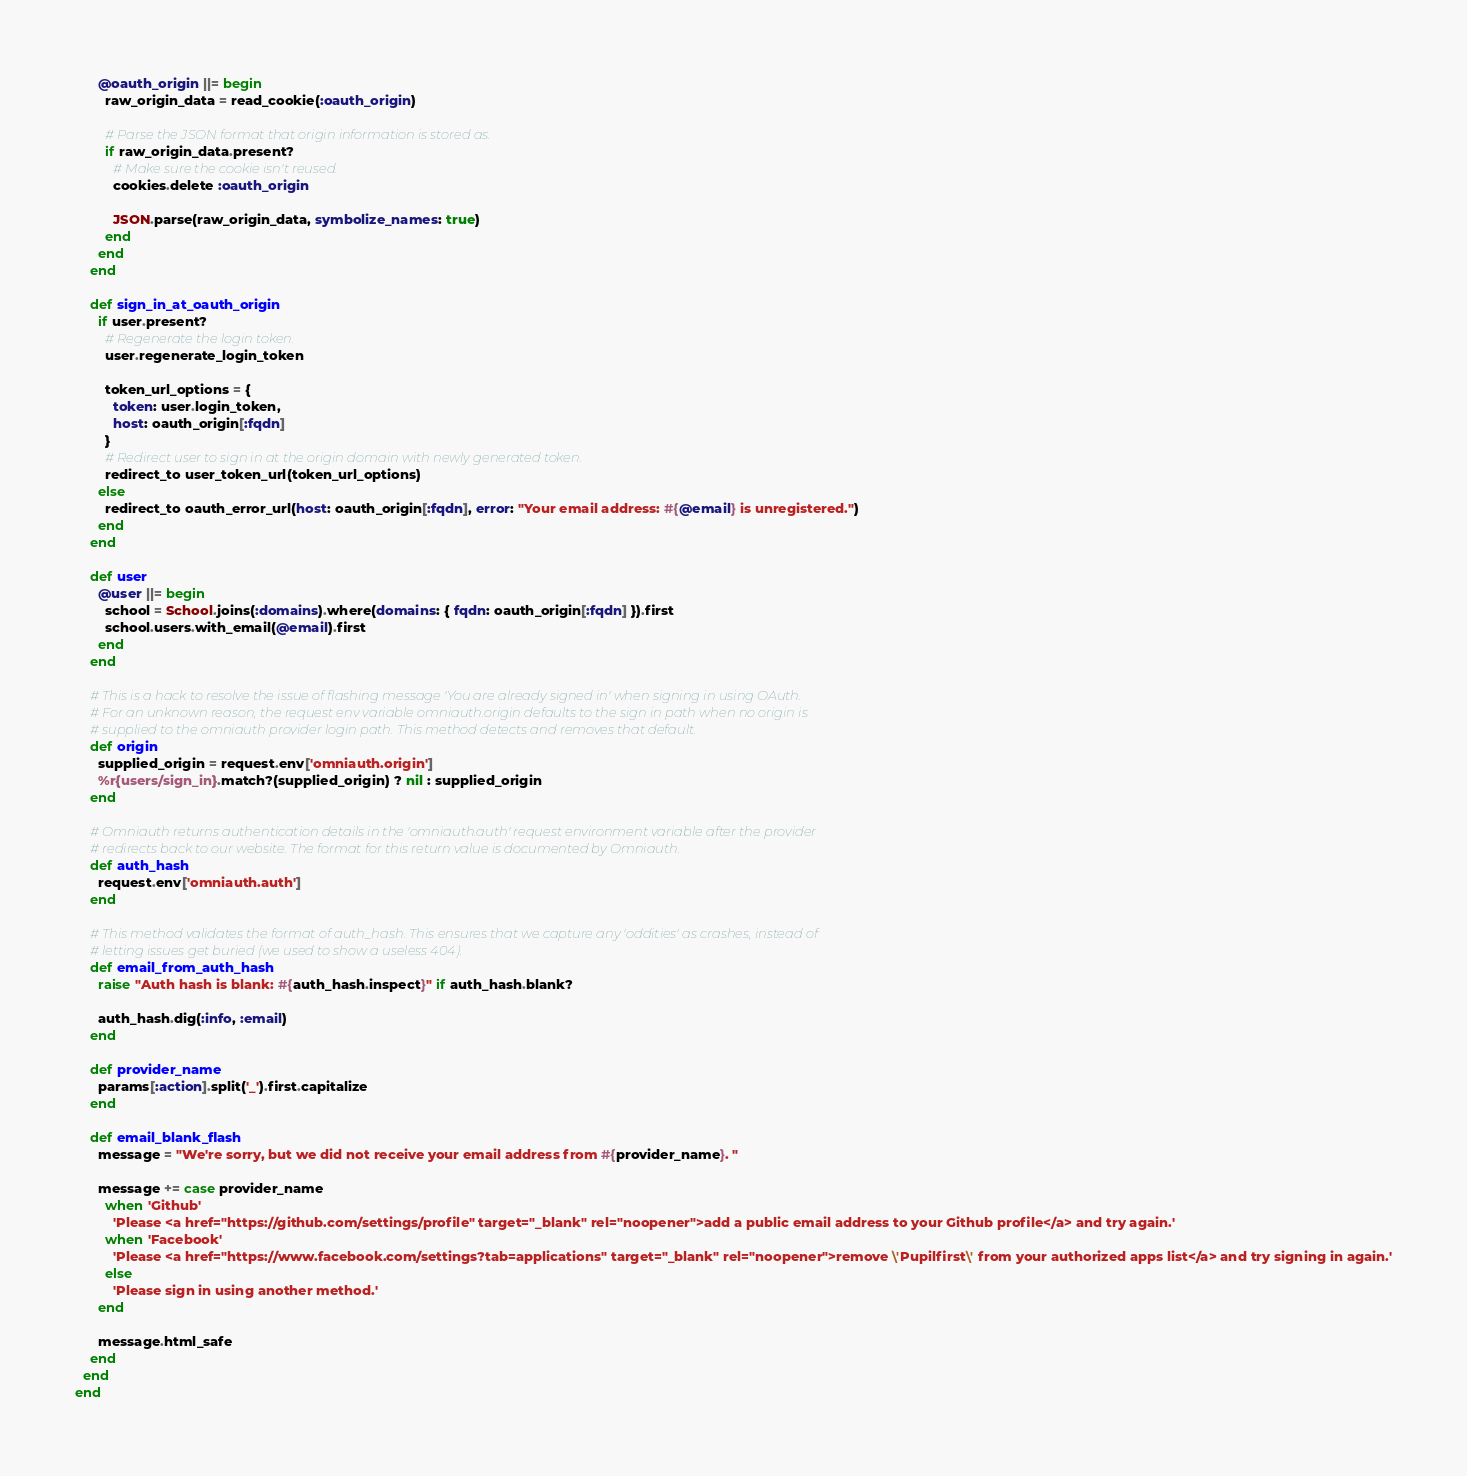Convert code to text. <code><loc_0><loc_0><loc_500><loc_500><_Ruby_>      @oauth_origin ||= begin
        raw_origin_data = read_cookie(:oauth_origin)

        # Parse the JSON format that origin information is stored as.
        if raw_origin_data.present?
          # Make sure the cookie isn't reused.
          cookies.delete :oauth_origin

          JSON.parse(raw_origin_data, symbolize_names: true)
        end
      end
    end

    def sign_in_at_oauth_origin
      if user.present?
        # Regenerate the login token.
        user.regenerate_login_token

        token_url_options = {
          token: user.login_token,
          host: oauth_origin[:fqdn]
        }
        # Redirect user to sign in at the origin domain with newly generated token.
        redirect_to user_token_url(token_url_options)
      else
        redirect_to oauth_error_url(host: oauth_origin[:fqdn], error: "Your email address: #{@email} is unregistered.")
      end
    end

    def user
      @user ||= begin
        school = School.joins(:domains).where(domains: { fqdn: oauth_origin[:fqdn] }).first
        school.users.with_email(@email).first
      end
    end

    # This is a hack to resolve the issue of flashing message 'You are already signed in' when signing in using OAuth.
    # For an unknown reason, the request env variable omniauth.origin defaults to the sign in path when no origin is
    # supplied to the omniauth provider login path. This method detects and removes that default.
    def origin
      supplied_origin = request.env['omniauth.origin']
      %r{users/sign_in}.match?(supplied_origin) ? nil : supplied_origin
    end

    # Omniauth returns authentication details in the 'omniauth.auth' request environment variable after the provider
    # redirects back to our website. The format for this return value is documented by Omniauth.
    def auth_hash
      request.env['omniauth.auth']
    end

    # This method validates the format of auth_hash. This ensures that we capture any 'oddities' as crashes, instead of
    # letting issues get buried (we used to show a useless 404).
    def email_from_auth_hash
      raise "Auth hash is blank: #{auth_hash.inspect}" if auth_hash.blank?

      auth_hash.dig(:info, :email)
    end

    def provider_name
      params[:action].split('_').first.capitalize
    end

    def email_blank_flash
      message = "We're sorry, but we did not receive your email address from #{provider_name}. "

      message += case provider_name
        when 'Github'
          'Please <a href="https://github.com/settings/profile" target="_blank" rel="noopener">add a public email address to your Github profile</a> and try again.'
        when 'Facebook'
          'Please <a href="https://www.facebook.com/settings?tab=applications" target="_blank" rel="noopener">remove \'Pupilfirst\' from your authorized apps list</a> and try signing in again.'
        else
          'Please sign in using another method.'
      end

      message.html_safe
    end
  end
end
</code> 